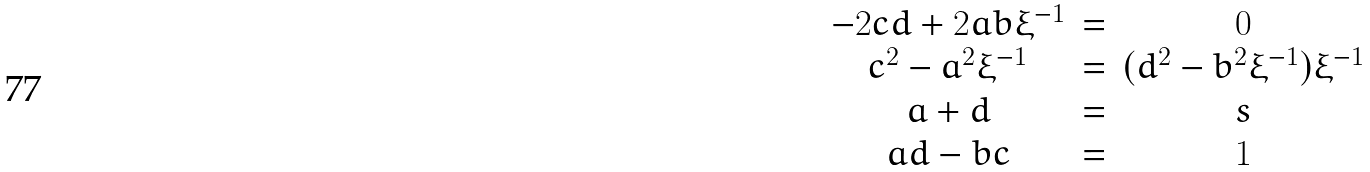<formula> <loc_0><loc_0><loc_500><loc_500>\begin{array} { c c c c c } - 2 c d + 2 a b \xi ^ { - 1 } & = & 0 \\ c ^ { 2 } - a ^ { 2 } \xi ^ { - 1 } & = & ( d ^ { 2 } - b ^ { 2 } \xi ^ { - 1 } ) \xi ^ { - 1 } \\ a + d & = & s \\ a d - b c & = & 1 \\ \end{array}</formula> 